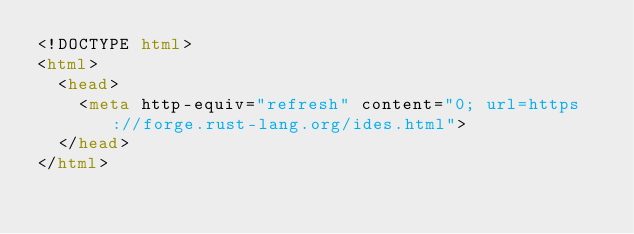Convert code to text. <code><loc_0><loc_0><loc_500><loc_500><_HTML_><!DOCTYPE html>
<html>
  <head>
    <meta http-equiv="refresh" content="0; url=https://forge.rust-lang.org/ides.html">
  </head>
</html>
</code> 